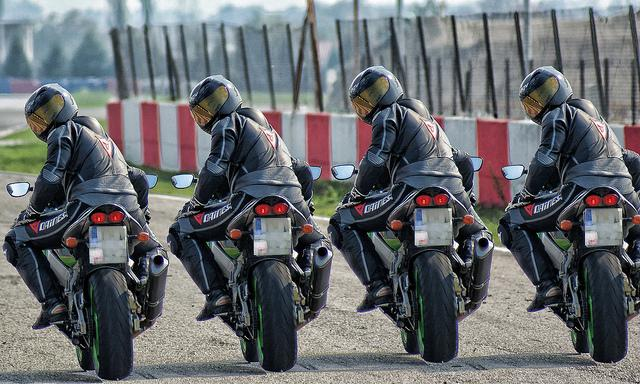What are the motorcycles riding on?

Choices:
A) asphalt
B) concrete
C) water
D) dirt asphalt 